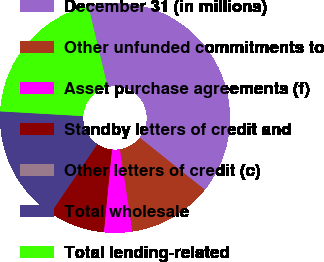Convert chart. <chart><loc_0><loc_0><loc_500><loc_500><pie_chart><fcel>December 31 (in millions)<fcel>Other unfunded commitments to<fcel>Asset purchase agreements (f)<fcel>Standby letters of credit and<fcel>Other letters of credit (c)<fcel>Total wholesale<fcel>Total lending-related<nl><fcel>39.47%<fcel>11.85%<fcel>3.96%<fcel>7.91%<fcel>0.02%<fcel>16.42%<fcel>20.36%<nl></chart> 